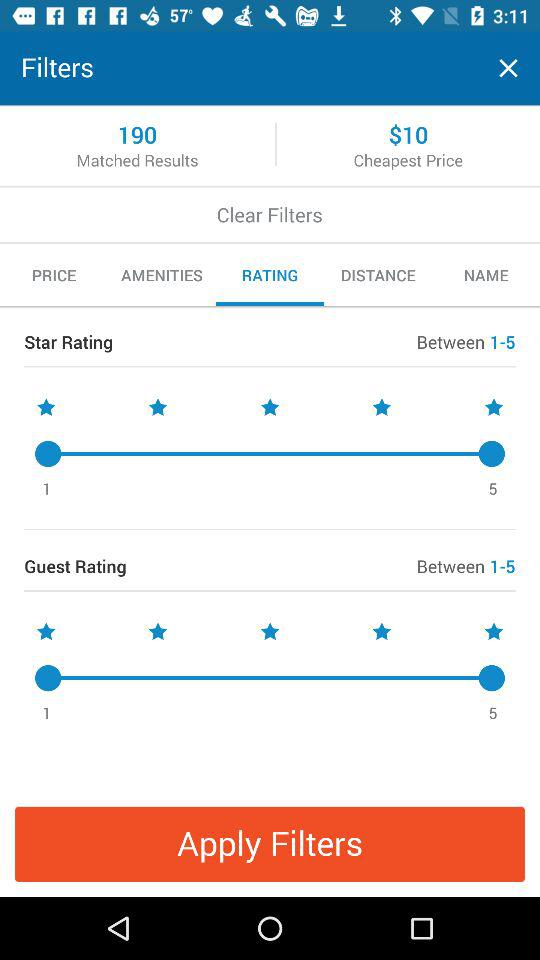How many star ratings are available for the guest rating filter?
Answer the question using a single word or phrase. 5 